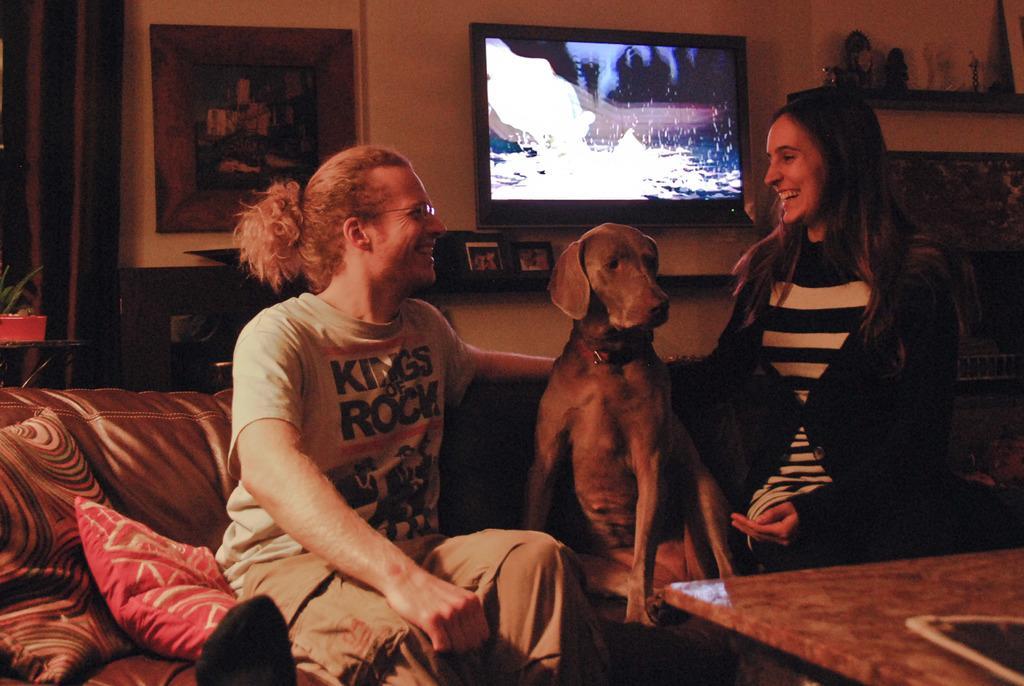Describe this image in one or two sentences. Here we can see a couple of people siting on a couch with a dog in the middle and behind them we can see a television and a portrait present 